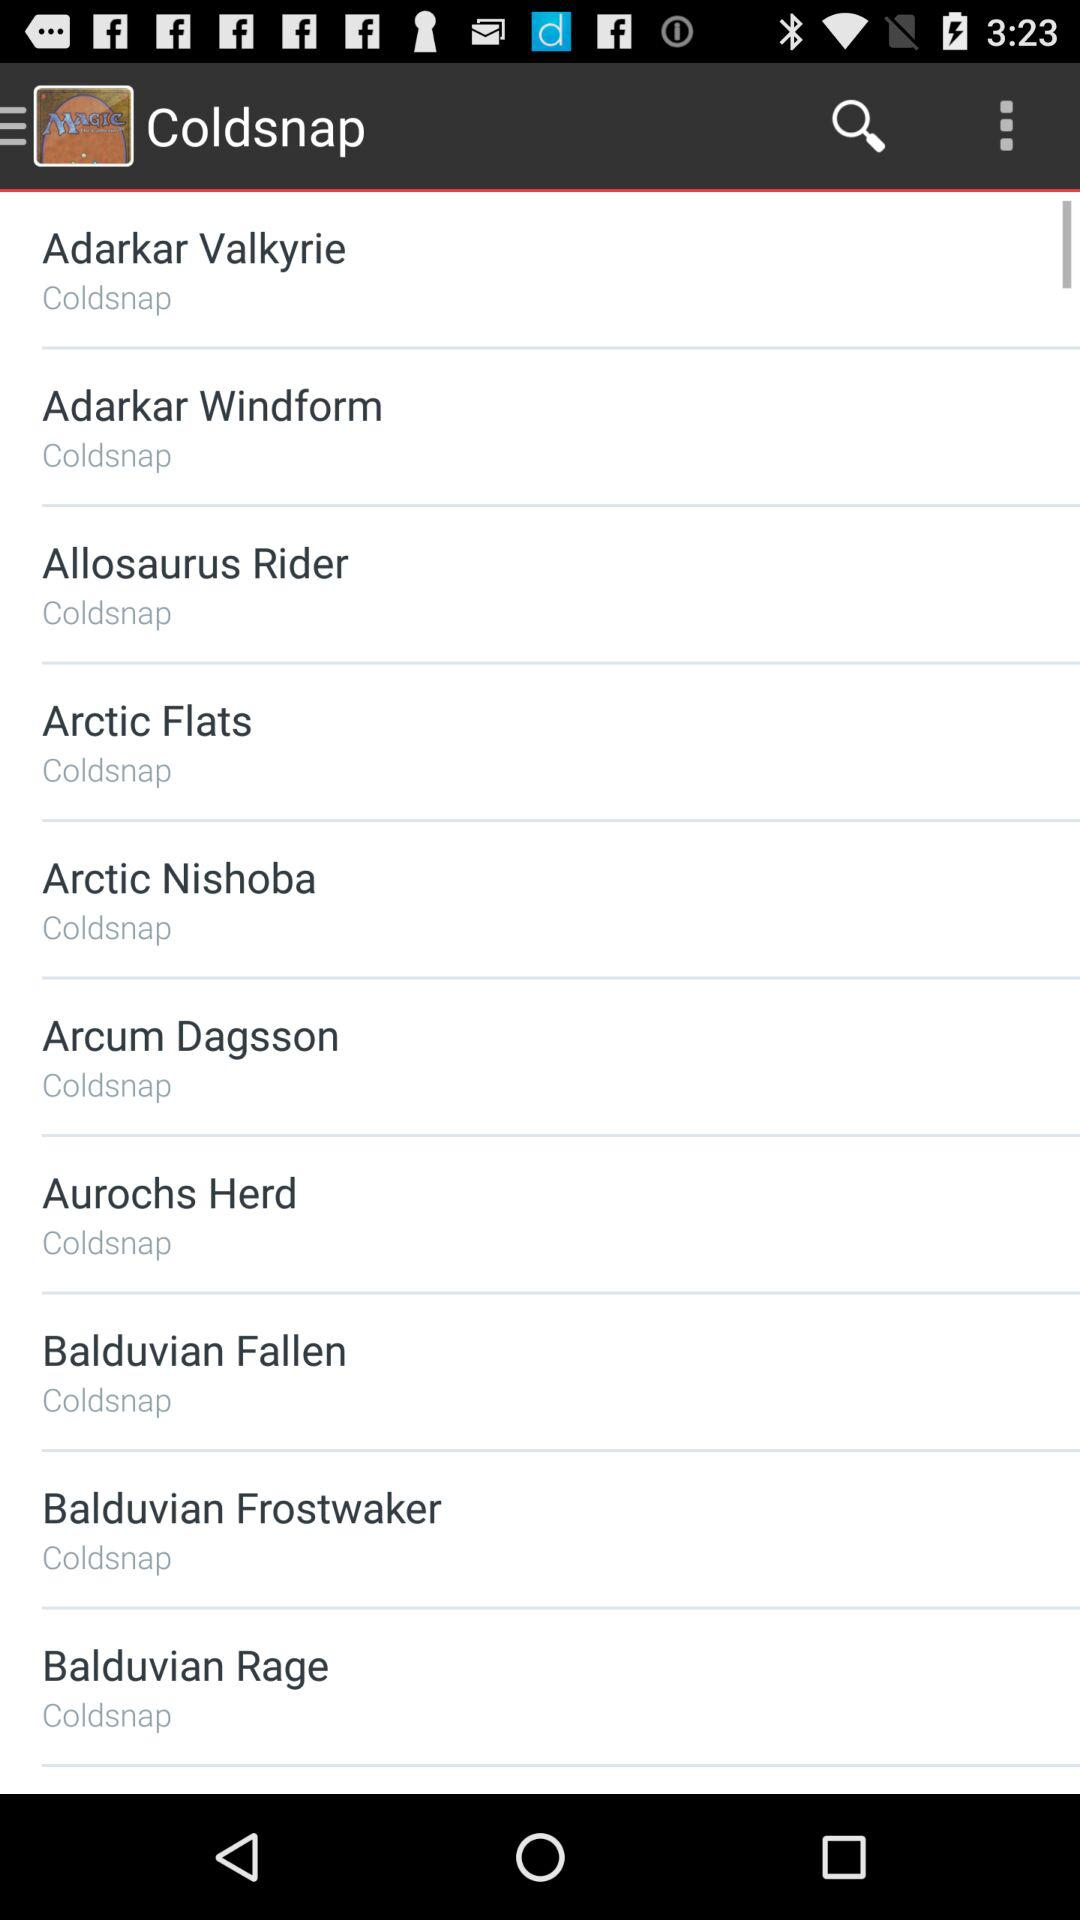How many cards have the Coldsnap set symbol?
Answer the question using a single word or phrase. 10 